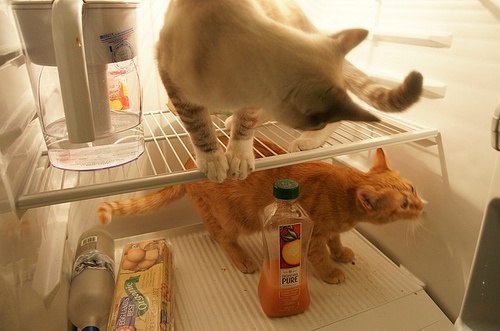Describe the objects in this image and their specific colors. I can see refrigerator in brown, olive, tan, maroon, and beige tones, cat in beige, maroon, olive, and tan tones, cat in beige, maroon, brown, and tan tones, bottle in beige, brown, and maroon tones, and bottle in beige, brown, olive, and tan tones in this image. 